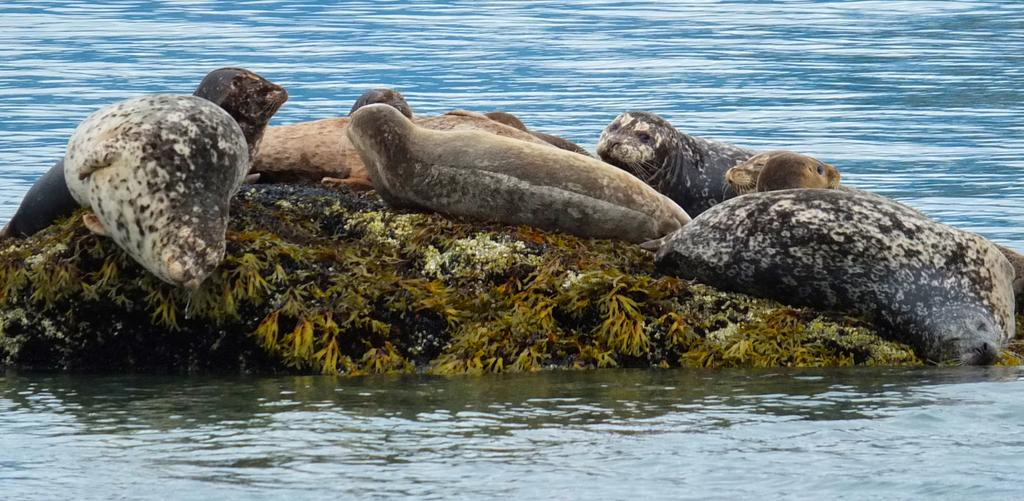What animals are present in the image? There are seals in the image. Where are the seals located? The seals are on a stone in the image. What is the stone situated on? The stone is in the middle of water. What can be seen in the background of the image? There is water visible in the background of the image. What can be seen in the foreground of the image? There is water visible in the foreground of the image. What type of sugar is being used to sweeten the water in the image? There is no sugar present in the image, and the water is not being sweetened. 